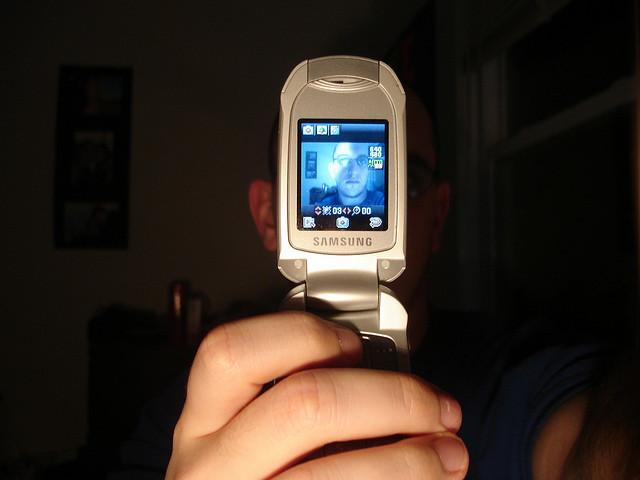What company makes the phone? Please explain your reasoning. samsung. Samsung makes the phone. 